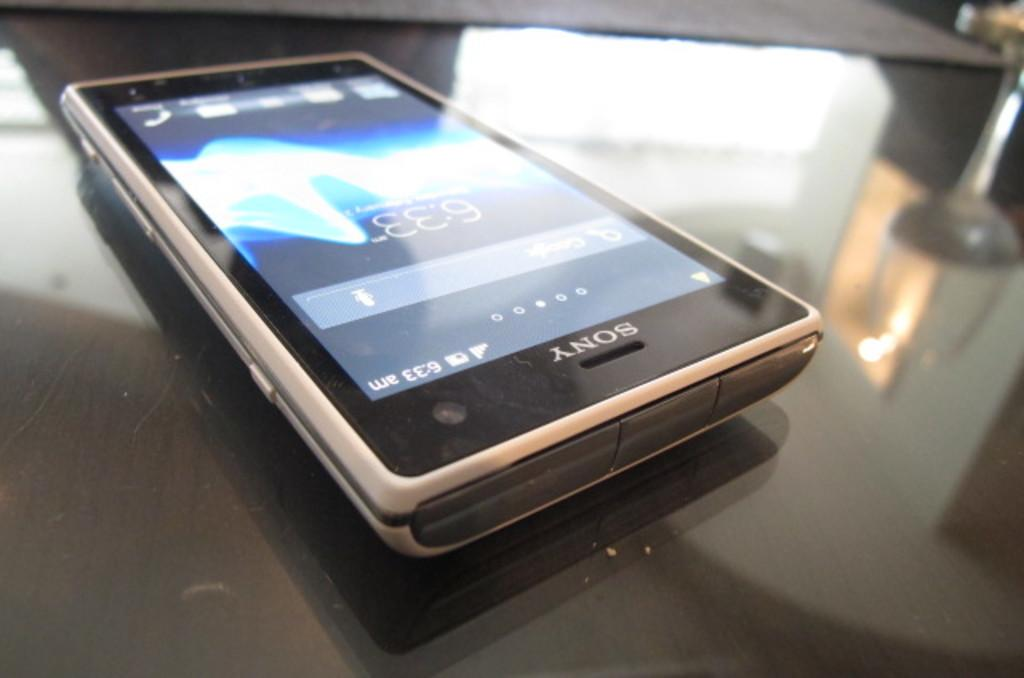Provide a one-sentence caption for the provided image. A Sony cell phone that is displaying 6:33 as the time. 